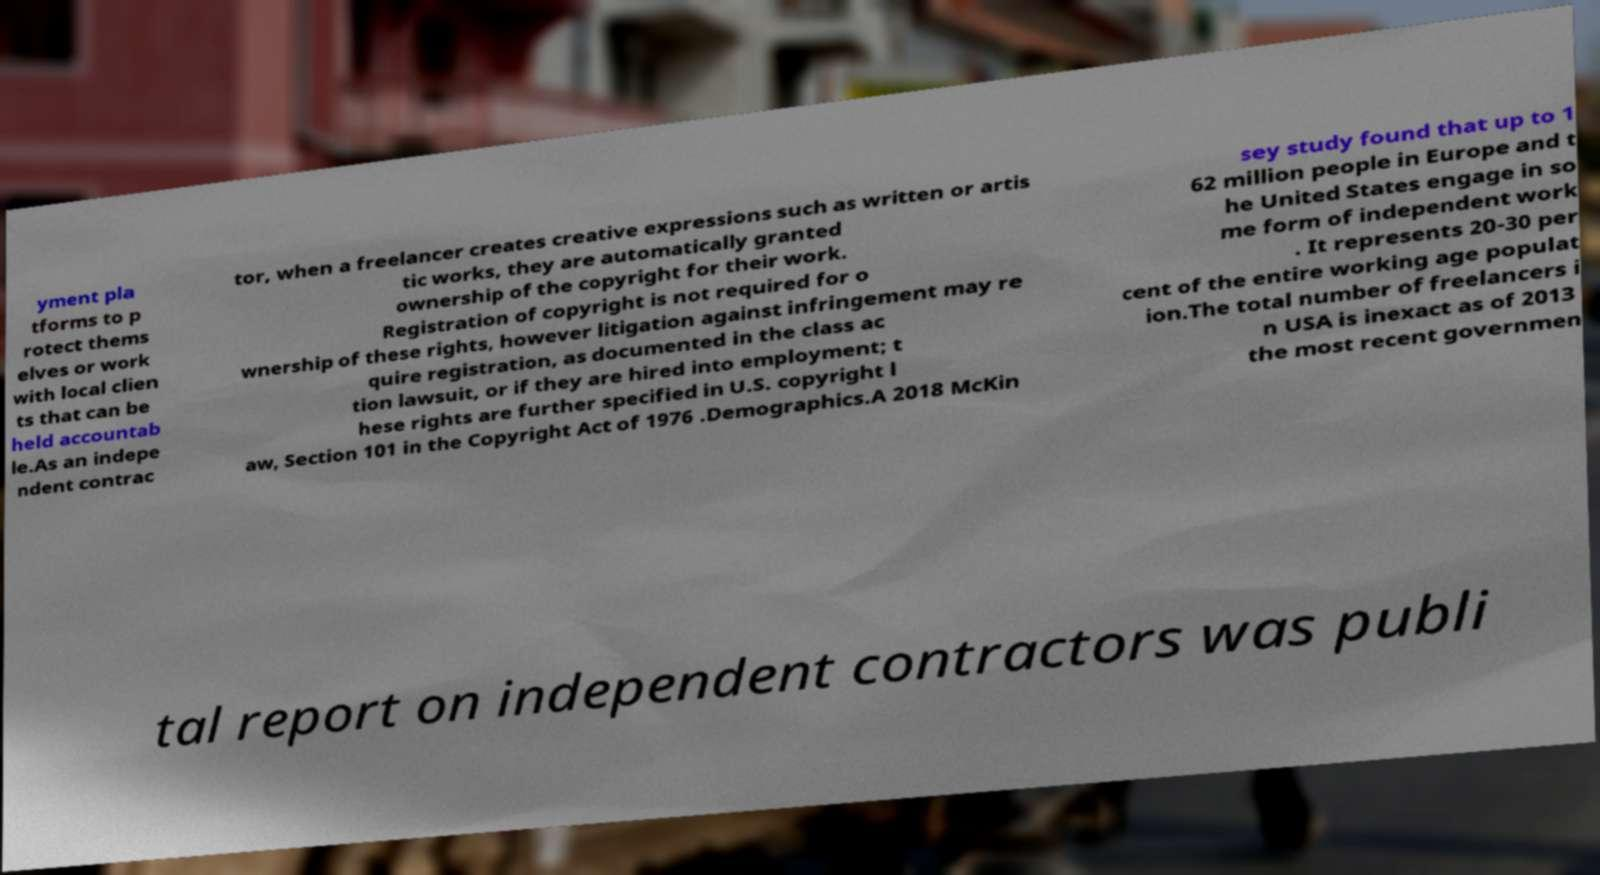Could you assist in decoding the text presented in this image and type it out clearly? yment pla tforms to p rotect thems elves or work with local clien ts that can be held accountab le.As an indepe ndent contrac tor, when a freelancer creates creative expressions such as written or artis tic works, they are automatically granted ownership of the copyright for their work. Registration of copyright is not required for o wnership of these rights, however litigation against infringement may re quire registration, as documented in the class ac tion lawsuit, or if they are hired into employment; t hese rights are further specified in U.S. copyright l aw, Section 101 in the Copyright Act of 1976 .Demographics.A 2018 McKin sey study found that up to 1 62 million people in Europe and t he United States engage in so me form of independent work . It represents 20-30 per cent of the entire working age populat ion.The total number of freelancers i n USA is inexact as of 2013 the most recent governmen tal report on independent contractors was publi 